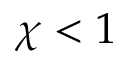Convert formula to latex. <formula><loc_0><loc_0><loc_500><loc_500>\chi < 1</formula> 